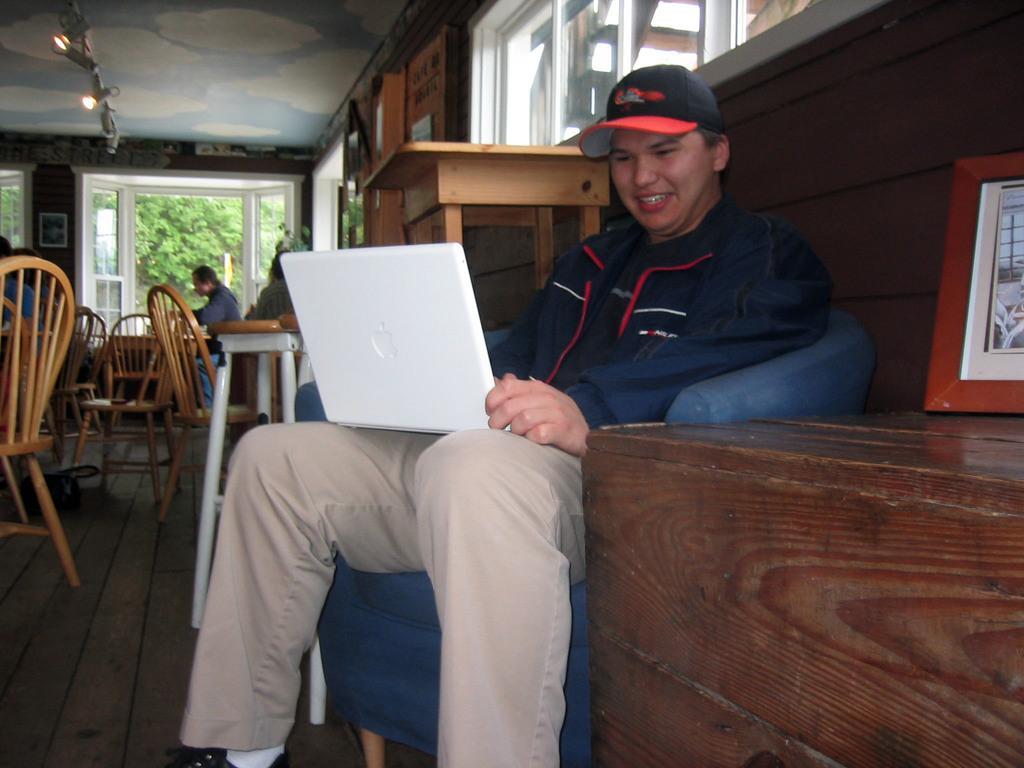Could you give a brief overview of what you see in this image? Here is the man sitting on the chair and smiling. He wore a cap,jerkin and trouser. he is holding a laptop which is white in color. This is a table with a photo frame on it. These are the chairs. I can see another person sitting on the chair. These are the windows. These are the lights attached to the rooftop. I can see frame attached to the wall. Here is another wooden table behind the man. At background I can see tree through the window. 